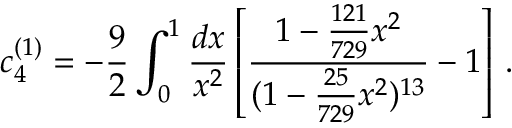<formula> <loc_0><loc_0><loc_500><loc_500>c _ { 4 } ^ { ( 1 ) } = - \frac { 9 } { 2 } \int _ { 0 } ^ { 1 } \frac { d x } { x ^ { 2 } } \left [ \frac { 1 - \frac { 1 2 1 } { 7 2 9 } x ^ { 2 } } { ( 1 - \frac { 2 5 } { 7 2 9 } x ^ { 2 } ) ^ { 1 3 } } - 1 \right ] \, .</formula> 